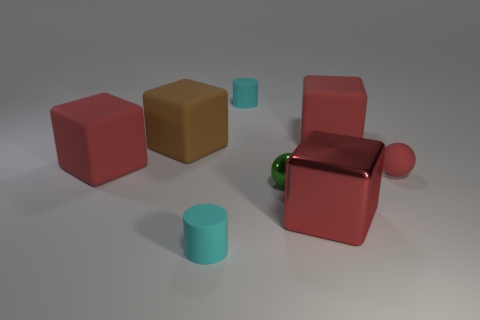Subtract all gray cylinders. How many red cubes are left? 3 Subtract all large shiny cubes. How many cubes are left? 3 Subtract 1 blocks. How many blocks are left? 3 Add 2 cubes. How many objects exist? 10 Subtract all brown blocks. How many blocks are left? 3 Subtract all spheres. How many objects are left? 6 Subtract all yellow blocks. Subtract all purple cylinders. How many blocks are left? 4 Subtract 0 purple cylinders. How many objects are left? 8 Subtract all large matte objects. Subtract all large brown blocks. How many objects are left? 4 Add 5 matte blocks. How many matte blocks are left? 8 